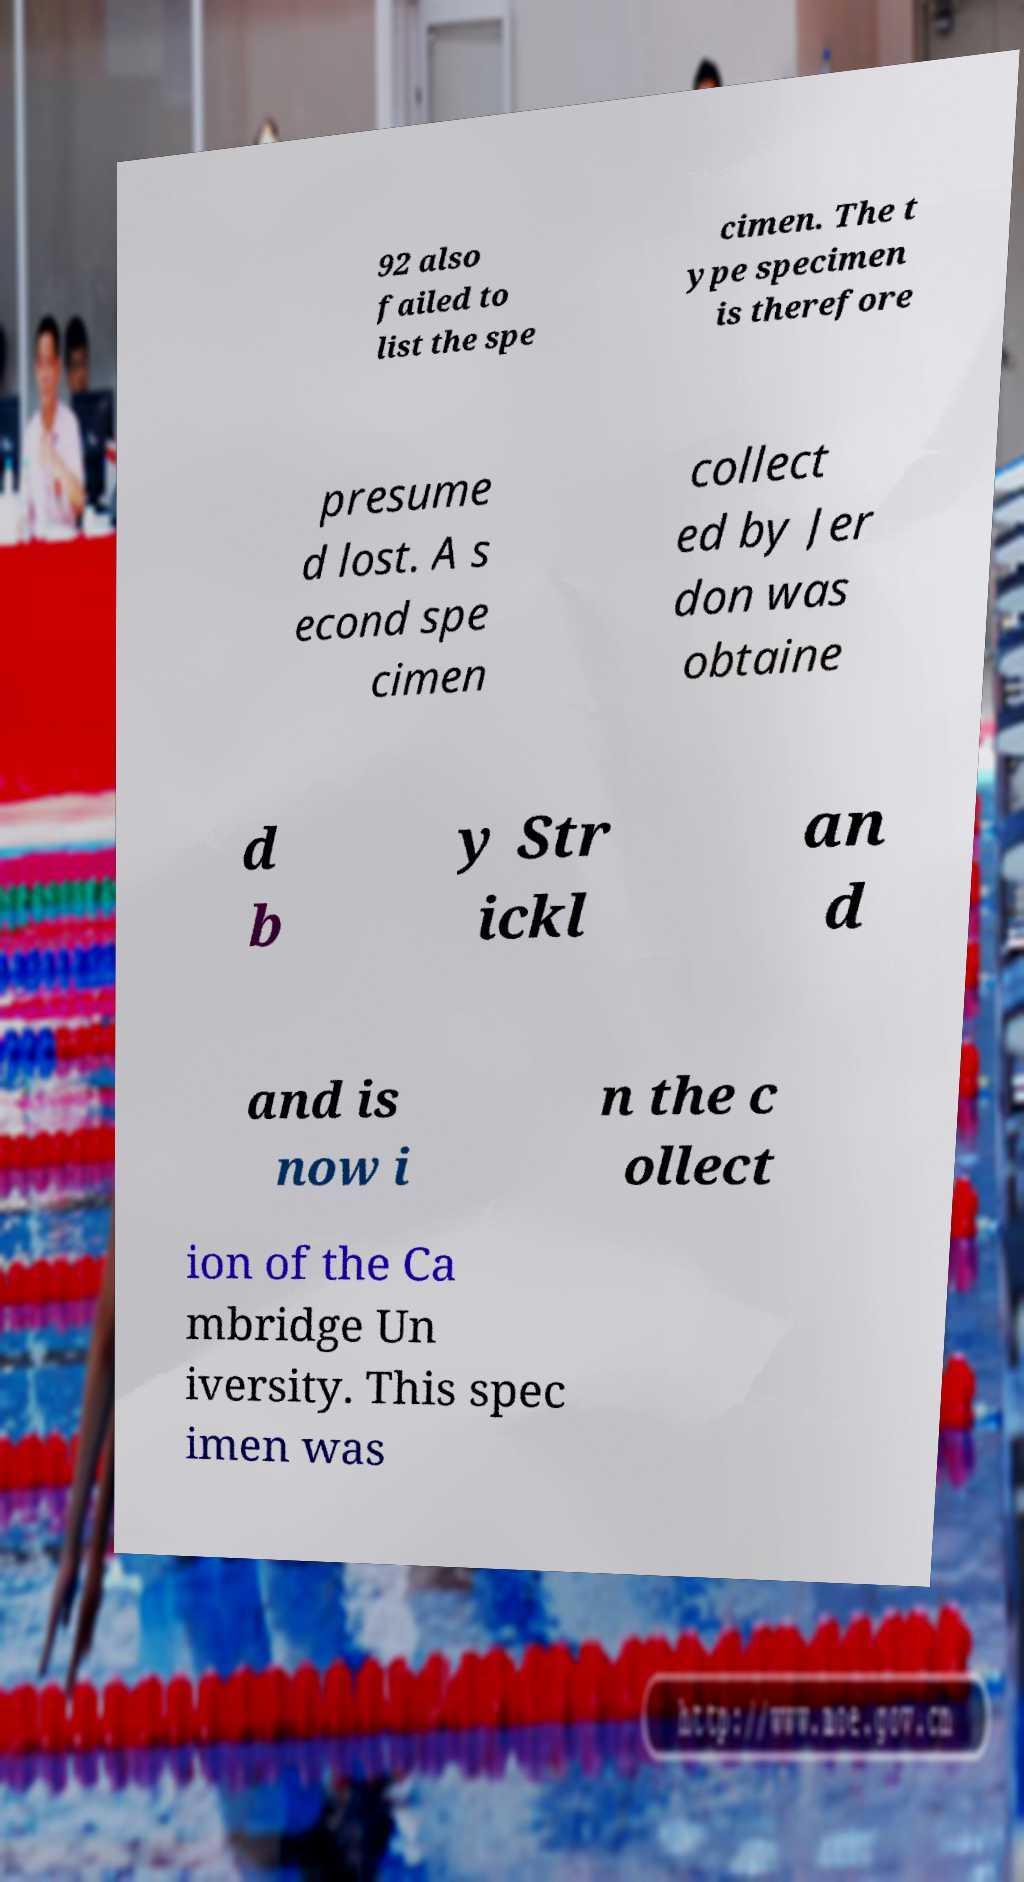For documentation purposes, I need the text within this image transcribed. Could you provide that? 92 also failed to list the spe cimen. The t ype specimen is therefore presume d lost. A s econd spe cimen collect ed by Jer don was obtaine d b y Str ickl an d and is now i n the c ollect ion of the Ca mbridge Un iversity. This spec imen was 